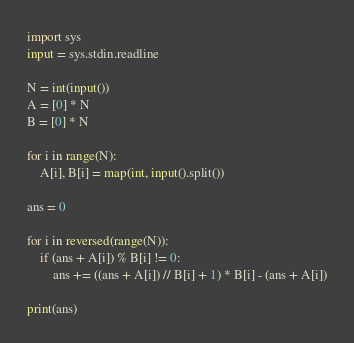<code> <loc_0><loc_0><loc_500><loc_500><_Python_>import sys
input = sys.stdin.readline

N = int(input())
A = [0] * N
B = [0] * N

for i in range(N):
    A[i], B[i] = map(int, input().split())

ans = 0

for i in reversed(range(N)):
    if (ans + A[i]) % B[i] != 0:
        ans += ((ans + A[i]) // B[i] + 1) * B[i] - (ans + A[i])

print(ans)</code> 